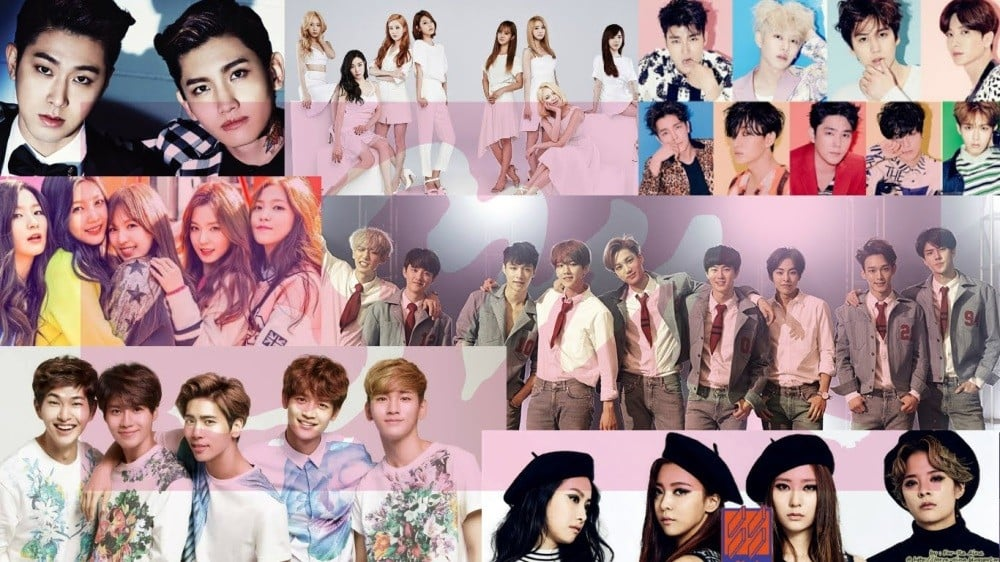Imagine this image as a scene in a futuristic city where these groups are leaders of different factions. How would their styles and presentation influence their followers? In a futuristic city where these K-pop groups are leaders of different factions, their styles and presentation would play a crucial role in shaping the identities and cultures of their followers. Each group's fashion choices would serve as a uniform and symbol of their respective faction, signifying values, philosophies, and social standings. The group with coordinated, sleek, and modern attire might represent a faction focused on innovation, technology, and progress, attracting followers who value efficiency and futurism. Another group with a more eclectic and colorful style could symbolize creativity, freedom, and artistic expression, drawing individuals who cherish originality and unconventional ideas. The varying textures and accessories could indicate different statuses or roles within the factions, such as leadership ranks or specialized skills. Ultimately, the visual and stylistic elements projected by these groups would become a form of non-verbal communication, creating a strong sense of belonging and pride among their followers, reinforcing faction identities and fostering a vibrant, diverse community within the futuristic city. What futuristic scenario could be explored if these groups were part of a narrative where their fashion choices had the power to control time and space? Imagine a narrative set in a futuristic world where fashion is more than just a visual statement—it is a conduit for manipulating time and space. In this universe, each K-pop group possesses unique sartorial elements imbued with temporal and spatial powers. The group dressed in sleek, metallic attire could harness the power of speed and acceleration, enabling them to move swiftly through time to alter historical events or prevent future catastrophes. Their fashion choices might include accessories that double as advanced technological devices, allowing them to open portals or create time loops. Another group, embodying vintage and retro styles, could have the ability to rewind and relive moments, providing them the opportunity to correct past mistakes or experience cherished memories anew. Their fashion might include timeworn fabrics that glow with an ethereal energy whenever they interact with the past. A third group, with an avant-garde and abstract fashion sense, could manipulate spatial dimensions, creating pocket universes or altering the fabric of reality to protect their city or trap adversaries. Their attire would constantly shift and morph, reflecting their control over space and adding to their enigmatic presence. In this narrative, the groups would become guardians of the temporal-spatial continuum, using their fashion-derived powers to maintain the balance of time and space, facing off against threats aiming to disrupt this delicate equilibrium. Through their adventures, they'd discover the profound impact of their abilities, not just on the world but also on their understanding of their own identities and destinies. 